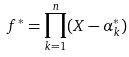Convert formula to latex. <formula><loc_0><loc_0><loc_500><loc_500>f ^ { * } = \prod _ { k = 1 } ^ { n } ( X - \alpha _ { k } ^ { * } )</formula> 